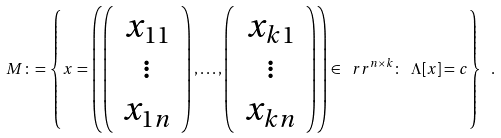<formula> <loc_0><loc_0><loc_500><loc_500>M \colon = \left \{ x = \left ( \left ( \begin{array} { c } x _ { 1 1 } \\ \vdots \\ x _ { 1 n } \end{array} \right ) , \dots , \left ( \begin{array} { c } x _ { k 1 } \\ \vdots \\ x _ { k n } \end{array} \right ) \right ) \in \ r r ^ { n \times k } \colon \ \Lambda [ x ] = c \right \} \ .</formula> 